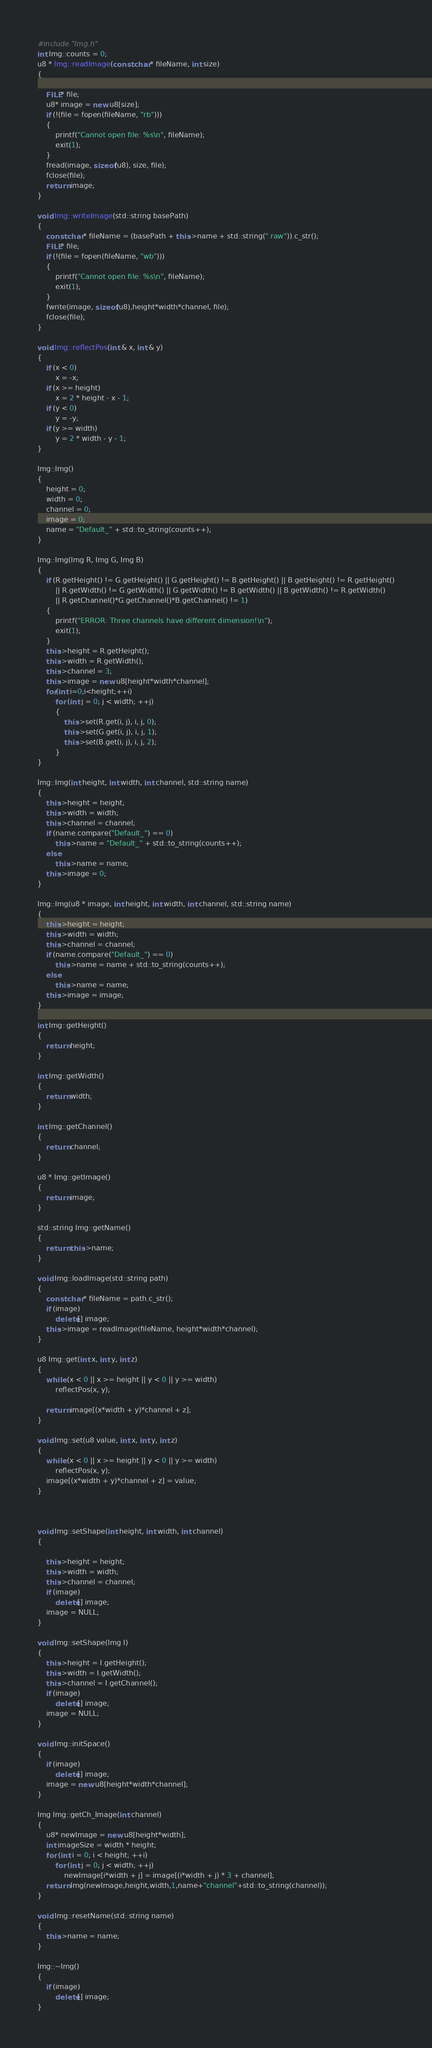Convert code to text. <code><loc_0><loc_0><loc_500><loc_500><_C++_>#include "Img.h"
int Img::counts = 0;
u8 * Img::readImage(const char* fileName, int size)
{

	FILE* file;
	u8* image = new u8[size];
	if (!(file = fopen(fileName, "rb")))
	{
		printf("Cannot open file: %s\n", fileName);
		exit(1);
	}
	fread(image, sizeof(u8), size, file);
	fclose(file);
	return image;
}

void Img::writeImage(std::string basePath)
{
	const char* fileName = (basePath + this->name + std::string(".raw")).c_str();
	FILE* file;
	if (!(file = fopen(fileName, "wb")))
	{
		printf("Cannot open file: %s\n", fileName);
		exit(1);
	}
	fwrite(image, sizeof(u8),height*width*channel, file);
	fclose(file);
}

void Img::reflectPos(int & x, int & y)
{
	if (x < 0)
		x = -x;
	if (x >= height)
		x = 2 * height - x - 1;
	if (y < 0)
		y = -y;
	if (y >= width)
		y = 2 * width - y - 1;
}

Img::Img()
{
	height = 0;
	width = 0;
	channel = 0;
	image = 0;
	name = "Default_" + std::to_string(counts++);
}

Img::Img(Img R, Img G, Img B)
{
	if (R.getHeight() != G.getHeight() || G.getHeight() != B.getHeight() || B.getHeight() != R.getHeight()
		|| R.getWidth() != G.getWidth() || G.getWidth() != B.getWidth() || B.getWidth() != R.getWidth()
		|| R.getChannel()*G.getChannel()*B.getChannel() != 1)
	{
		printf("ERROR: Three channels have different dimension!\n");
		exit(1);
	}
	this->height = R.getHeight();
	this->width = R.getWidth();
	this->channel = 3;
	this->image = new u8[height*width*channel];
	for(int i=0;i<height;++i)
		for (int j = 0; j < width; ++j)
		{
			this->set(R.get(i, j), i, j, 0);
			this->set(G.get(i, j), i, j, 1);
			this->set(B.get(i, j), i, j, 2);
		}
}

Img::Img(int height, int width, int channel, std::string name)
{
	this->height = height;
	this->width = width;
	this->channel = channel;
	if (name.compare("Default_") == 0)
		this->name = "Default_" + std::to_string(counts++);
	else
		this->name = name;
	this->image = 0;
}

Img::Img(u8 * image, int height, int width, int channel, std::string name)
{
	this->height = height;
	this->width = width;
	this->channel = channel;
	if (name.compare("Default_") == 0)
		this->name = name + std::to_string(counts++);
	else
		this->name = name;
	this->image = image;
}

int Img::getHeight()
{
	return height;
}

int Img::getWidth()
{
	return width;
}

int Img::getChannel()
{
	return channel;
}

u8 * Img::getImage()
{
	return image;
}

std::string Img::getName()
{
	return this->name;
}

void Img::loadImage(std::string path)
{
	const char* fileName = path.c_str();
	if (image)
		delete[] image;
	this->image = readImage(fileName, height*width*channel);
}

u8 Img::get(int x, int y, int z)
{
	while (x < 0 || x >= height || y < 0 || y >= width)
		reflectPos(x, y);
	
	return image[(x*width + y)*channel + z];
}

void Img::set(u8 value, int x, int y, int z)
{
	while (x < 0 || x >= height || y < 0 || y >= width)
		reflectPos(x, y);
	image[(x*width + y)*channel + z] = value;
}



void Img::setShape(int height, int width, int channel)
{	
	
	this->height = height;
	this->width = width;
	this->channel = channel;
	if (image)
		delete[] image;
	image = NULL;
}

void Img::setShape(Img I)
{
	this->height = I.getHeight();
	this->width = I.getWidth();
	this->channel = I.getChannel();
	if (image)
		delete[] image;
	image = NULL;
}

void Img::initSpace()
{
	if (image)
		delete[] image;
	image = new u8[height*width*channel];
}

Img Img::getCh_Image(int channel)
{
	u8* newImage = new u8[height*width];
	int imageSize = width * height;
	for (int i = 0; i < height; ++i)
		for (int j = 0; j < width; ++j)
			newImage[i*width + j] = image[(i*width + j) * 3 + channel];
	return Img(newImage,height,width,1,name+"channel"+std::to_string(channel));
}

void Img::resetName(std::string name)
{
	this->name = name;
}

Img::~Img()
{
	if (image)
		delete[] image;
}
</code> 